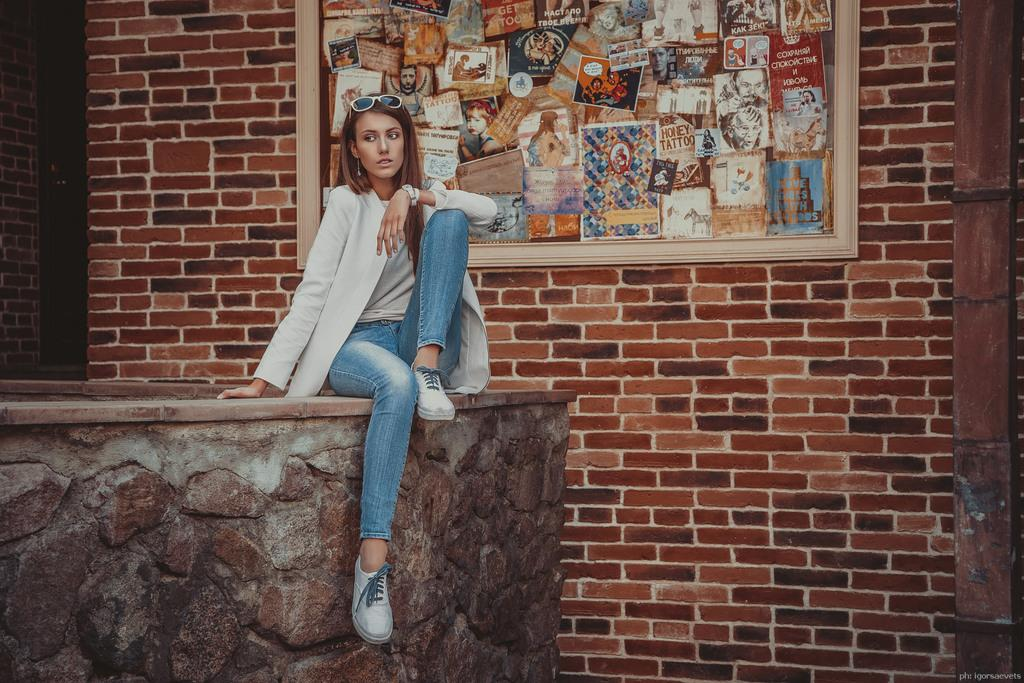What is the girl doing in the image? The girl is sitting on a rock in the image. What is the girl's focus in the image? The girl is staring at something. What can be seen in the background of the image? There is a brick wall in the background of the image. Is there any additional detail on the brick wall? Yes, there is a photo frame on the wall in the background. What type of cactus can be seen growing on the rock the girl is sitting on? There is no cactus present in the image; the girl is sitting on a rock with no visible plants. 